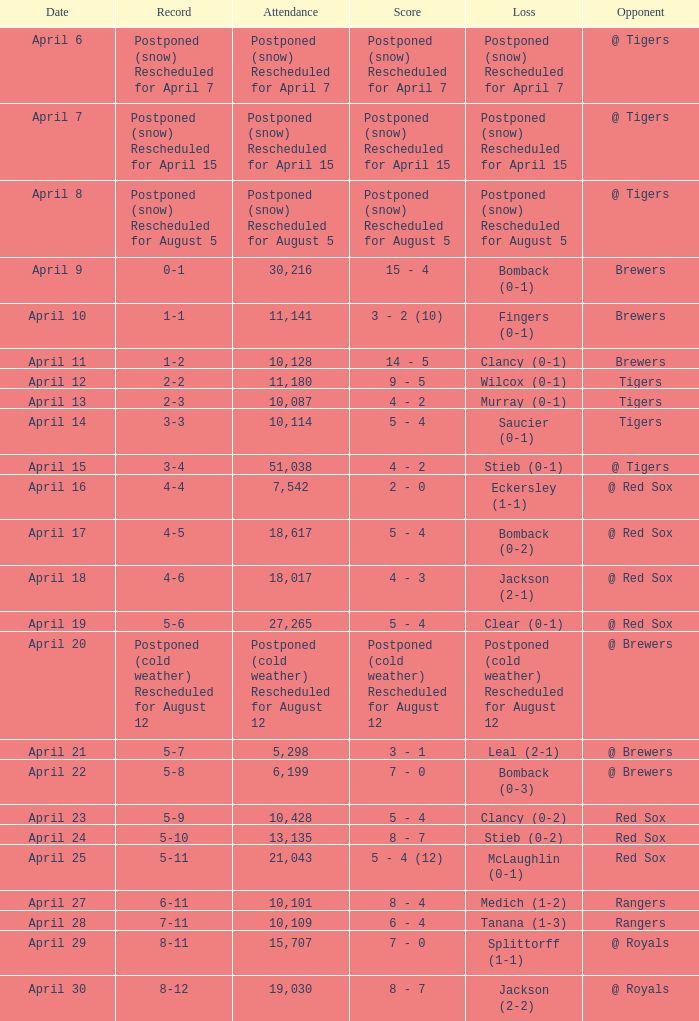What was the date for the game that had an attendance of 10,101? April 27. 